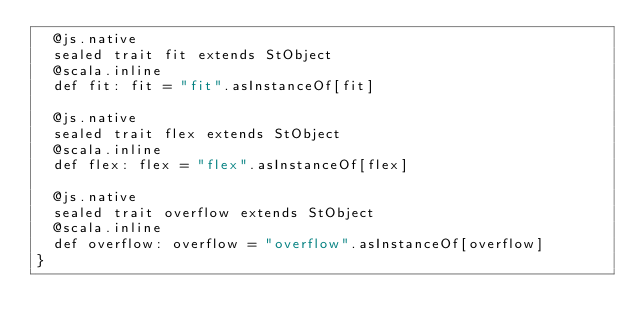<code> <loc_0><loc_0><loc_500><loc_500><_Scala_>  @js.native
  sealed trait fit extends StObject
  @scala.inline
  def fit: fit = "fit".asInstanceOf[fit]
  
  @js.native
  sealed trait flex extends StObject
  @scala.inline
  def flex: flex = "flex".asInstanceOf[flex]
  
  @js.native
  sealed trait overflow extends StObject
  @scala.inline
  def overflow: overflow = "overflow".asInstanceOf[overflow]
}
</code> 